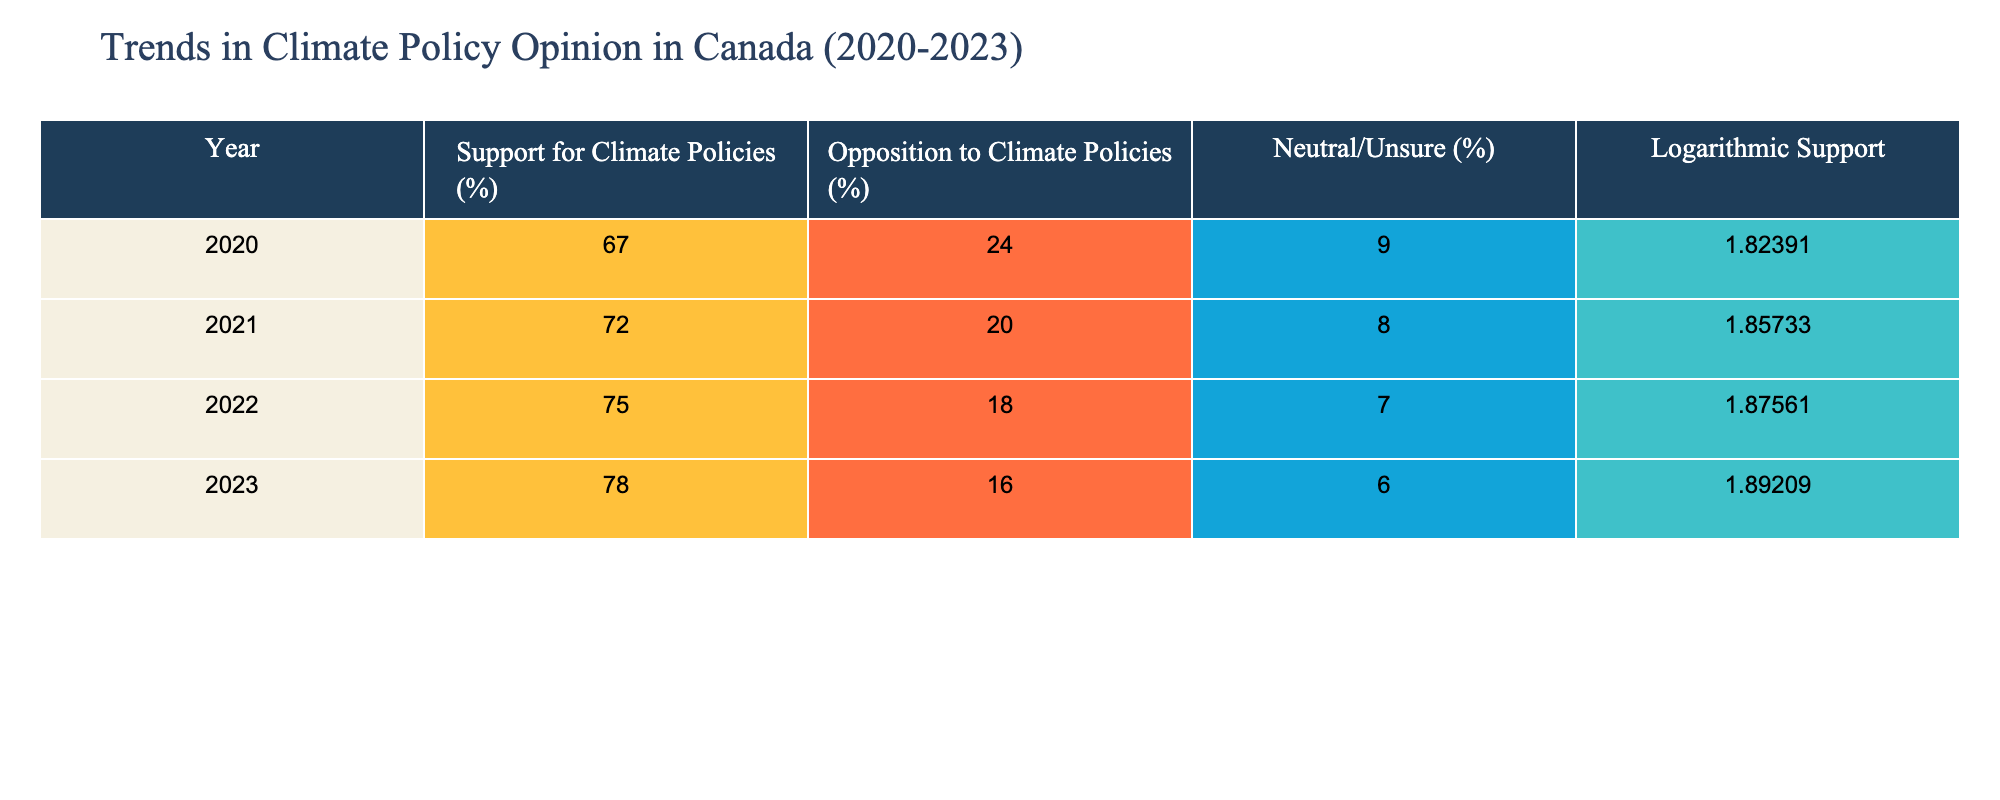What was the percentage of opposition to climate policies in 2021? In the row for the year 2021, the table shows the value under "Opposition to Climate Policies (%)". This value is 20%.
Answer: 20% What is the logarithmic support value for climate policies in 2022? In the row for the year 2022, the table lists the "Logarithmic Support" value. This value is 1.87561.
Answer: 1.87561 By how much did the support for climate policies increase from 2020 to 2023? To find the increase, subtract the support percentage in 2020 (67%) from that in 2023 (78%): 78% - 67% = 11%.
Answer: 11% Was there a decrease in the percentage of neutral/unsure respondents from 2020 to 2023? Check the "Neutral/Unsure (%)" for both 2020 and 2023. In 2020 it is 9%, and in 2023 it is 6%, confirming a decrease.
Answer: Yes What is the average percentage of support for climate policies over the years presented (2020 to 2023)? Sum the support percentages: 67% + 72% + 75% + 78% = 292%. There are 4 years, so the average is 292% / 4 = 73%.
Answer: 73% Which year saw the highest percentage of support for climate policies? By inspecting the "Support for Climate Policies (%)" column, identify the highest value which is 78%, corresponding to the year 2023.
Answer: 2023 What is the difference in opposition percentages between the years 2020 and 2022? Subtract the opposition percentage in 2022 (18%) from that in 2020 (24%): 24% - 18% = 6%.
Answer: 6% Is the opposition to climate policies greater than the neutral/unsure respondents in all the observed years? Check for each year if the "Opposition to Climate Policies (%)" is greater than the "Neutral/Unsure (%)". It is true for all years: 2020 (24% vs 9%), 2021 (20% vs 8%), 2022 (18% vs 7%), and 2023 (16% vs 6%).
Answer: Yes 